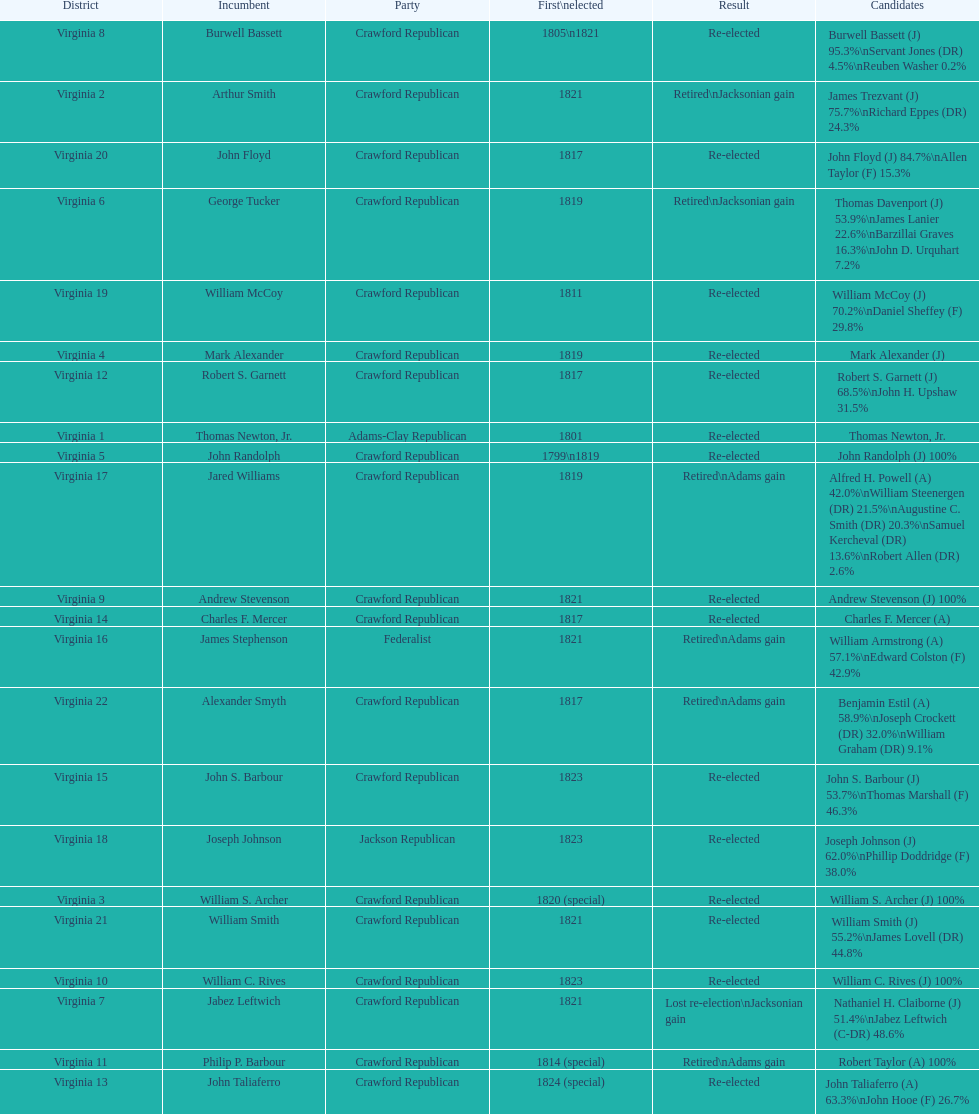Tell me the number of people first elected in 1817. 4. Would you be able to parse every entry in this table? {'header': ['District', 'Incumbent', 'Party', 'First\\nelected', 'Result', 'Candidates'], 'rows': [['Virginia 8', 'Burwell Bassett', 'Crawford Republican', '1805\\n1821', 'Re-elected', 'Burwell Bassett (J) 95.3%\\nServant Jones (DR) 4.5%\\nReuben Washer 0.2%'], ['Virginia 2', 'Arthur Smith', 'Crawford Republican', '1821', 'Retired\\nJacksonian gain', 'James Trezvant (J) 75.7%\\nRichard Eppes (DR) 24.3%'], ['Virginia 20', 'John Floyd', 'Crawford Republican', '1817', 'Re-elected', 'John Floyd (J) 84.7%\\nAllen Taylor (F) 15.3%'], ['Virginia 6', 'George Tucker', 'Crawford Republican', '1819', 'Retired\\nJacksonian gain', 'Thomas Davenport (J) 53.9%\\nJames Lanier 22.6%\\nBarzillai Graves 16.3%\\nJohn D. Urquhart 7.2%'], ['Virginia 19', 'William McCoy', 'Crawford Republican', '1811', 'Re-elected', 'William McCoy (J) 70.2%\\nDaniel Sheffey (F) 29.8%'], ['Virginia 4', 'Mark Alexander', 'Crawford Republican', '1819', 'Re-elected', 'Mark Alexander (J)'], ['Virginia 12', 'Robert S. Garnett', 'Crawford Republican', '1817', 'Re-elected', 'Robert S. Garnett (J) 68.5%\\nJohn H. Upshaw 31.5%'], ['Virginia 1', 'Thomas Newton, Jr.', 'Adams-Clay Republican', '1801', 'Re-elected', 'Thomas Newton, Jr.'], ['Virginia 5', 'John Randolph', 'Crawford Republican', '1799\\n1819', 'Re-elected', 'John Randolph (J) 100%'], ['Virginia 17', 'Jared Williams', 'Crawford Republican', '1819', 'Retired\\nAdams gain', 'Alfred H. Powell (A) 42.0%\\nWilliam Steenergen (DR) 21.5%\\nAugustine C. Smith (DR) 20.3%\\nSamuel Kercheval (DR) 13.6%\\nRobert Allen (DR) 2.6%'], ['Virginia 9', 'Andrew Stevenson', 'Crawford Republican', '1821', 'Re-elected', 'Andrew Stevenson (J) 100%'], ['Virginia 14', 'Charles F. Mercer', 'Crawford Republican', '1817', 'Re-elected', 'Charles F. Mercer (A)'], ['Virginia 16', 'James Stephenson', 'Federalist', '1821', 'Retired\\nAdams gain', 'William Armstrong (A) 57.1%\\nEdward Colston (F) 42.9%'], ['Virginia 22', 'Alexander Smyth', 'Crawford Republican', '1817', 'Retired\\nAdams gain', 'Benjamin Estil (A) 58.9%\\nJoseph Crockett (DR) 32.0%\\nWilliam Graham (DR) 9.1%'], ['Virginia 15', 'John S. Barbour', 'Crawford Republican', '1823', 'Re-elected', 'John S. Barbour (J) 53.7%\\nThomas Marshall (F) 46.3%'], ['Virginia 18', 'Joseph Johnson', 'Jackson Republican', '1823', 'Re-elected', 'Joseph Johnson (J) 62.0%\\nPhillip Doddridge (F) 38.0%'], ['Virginia 3', 'William S. Archer', 'Crawford Republican', '1820 (special)', 'Re-elected', 'William S. Archer (J) 100%'], ['Virginia 21', 'William Smith', 'Crawford Republican', '1821', 'Re-elected', 'William Smith (J) 55.2%\\nJames Lovell (DR) 44.8%'], ['Virginia 10', 'William C. Rives', 'Crawford Republican', '1823', 'Re-elected', 'William C. Rives (J) 100%'], ['Virginia 7', 'Jabez Leftwich', 'Crawford Republican', '1821', 'Lost re-election\\nJacksonian gain', 'Nathaniel H. Claiborne (J) 51.4%\\nJabez Leftwich (C-DR) 48.6%'], ['Virginia 11', 'Philip P. Barbour', 'Crawford Republican', '1814 (special)', 'Retired\\nAdams gain', 'Robert Taylor (A) 100%'], ['Virginia 13', 'John Taliaferro', 'Crawford Republican', '1824 (special)', 'Re-elected', 'John Taliaferro (A) 63.3%\\nJohn Hooe (F) 26.7%']]} 